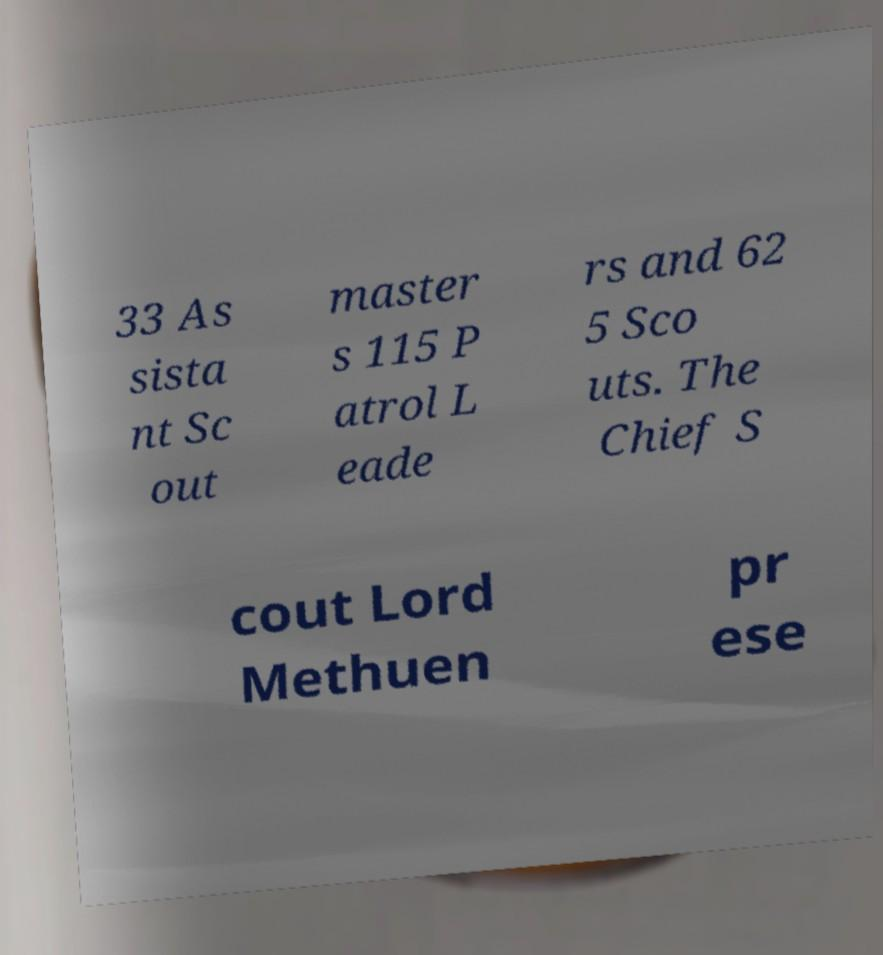Can you read and provide the text displayed in the image?This photo seems to have some interesting text. Can you extract and type it out for me? 33 As sista nt Sc out master s 115 P atrol L eade rs and 62 5 Sco uts. The Chief S cout Lord Methuen pr ese 